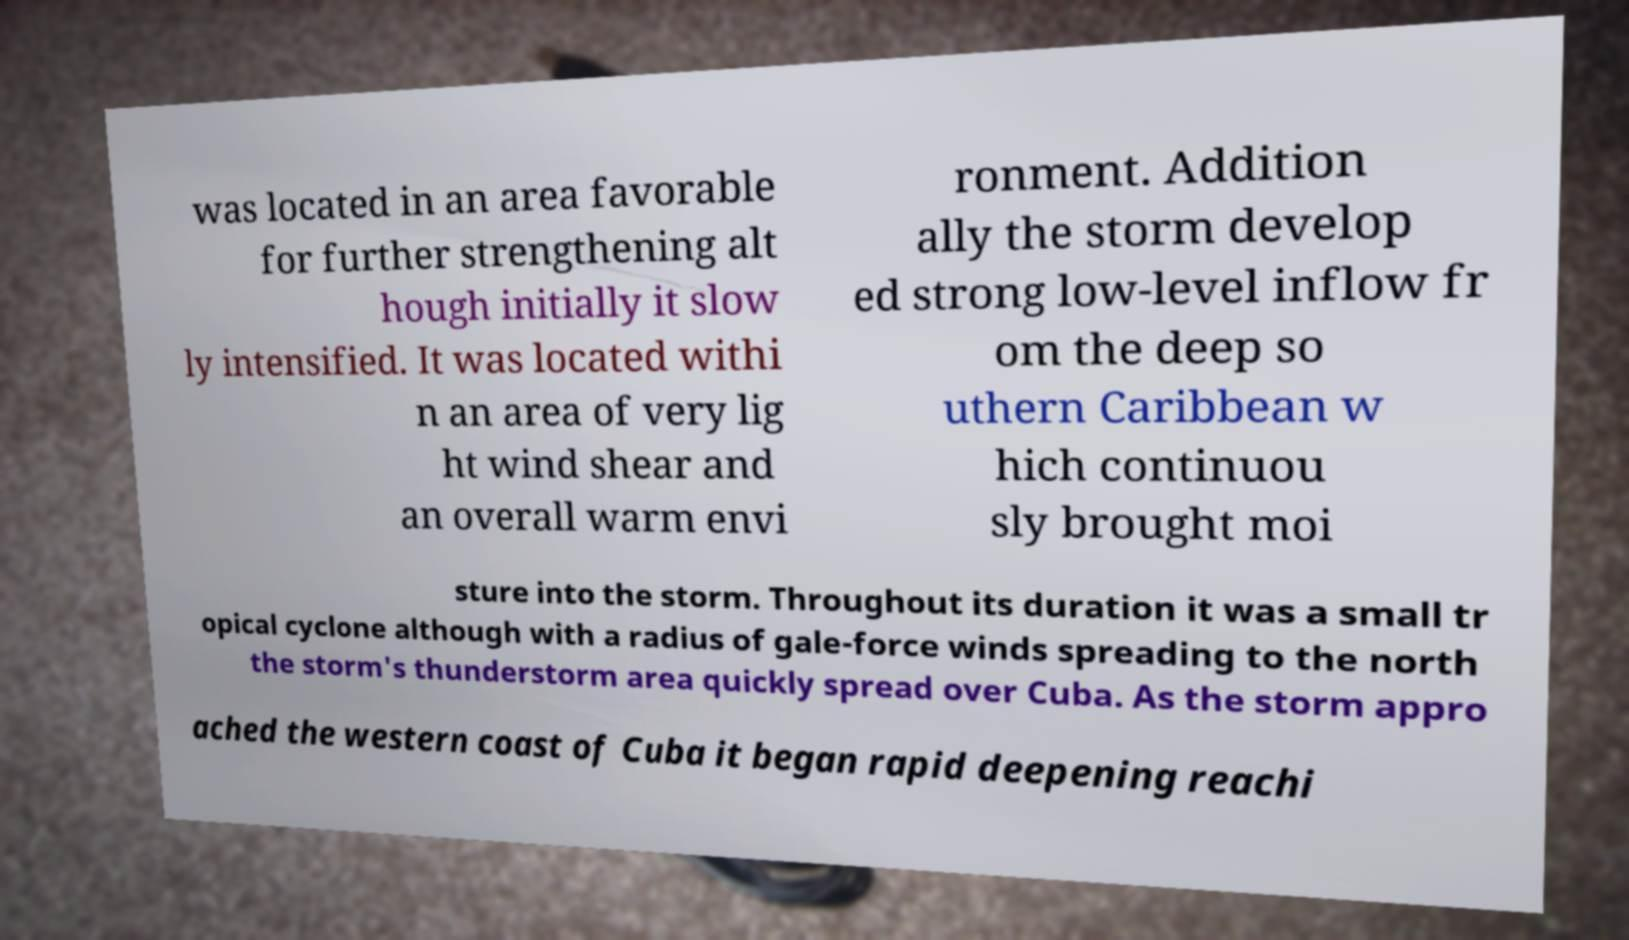There's text embedded in this image that I need extracted. Can you transcribe it verbatim? was located in an area favorable for further strengthening alt hough initially it slow ly intensified. It was located withi n an area of very lig ht wind shear and an overall warm envi ronment. Addition ally the storm develop ed strong low-level inflow fr om the deep so uthern Caribbean w hich continuou sly brought moi sture into the storm. Throughout its duration it was a small tr opical cyclone although with a radius of gale-force winds spreading to the north the storm's thunderstorm area quickly spread over Cuba. As the storm appro ached the western coast of Cuba it began rapid deepening reachi 